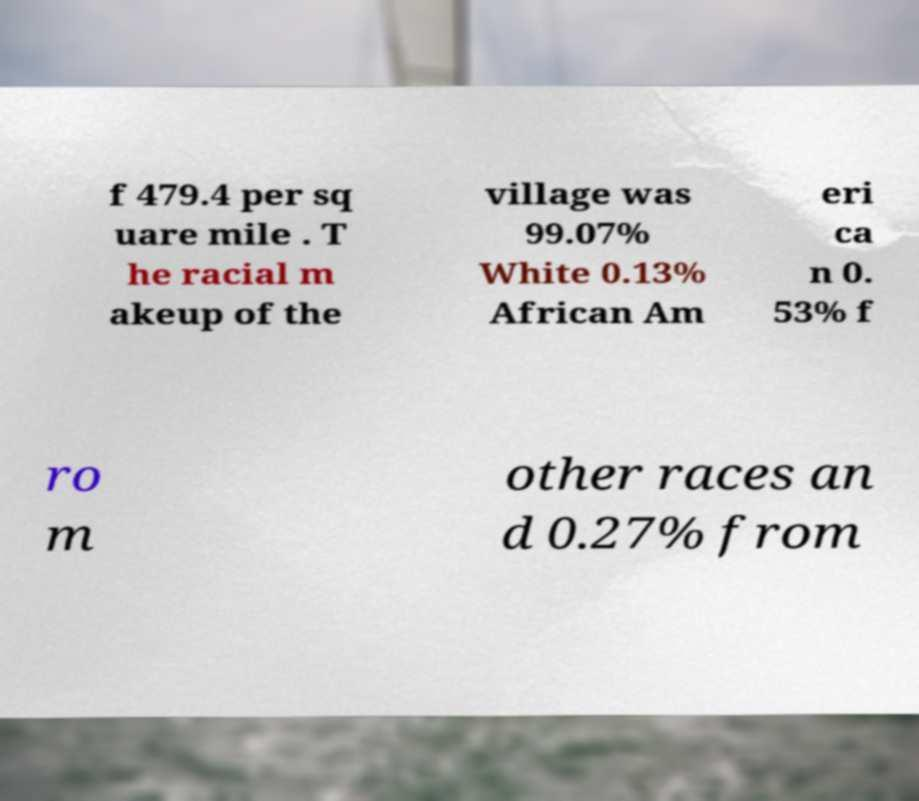Can you read and provide the text displayed in the image?This photo seems to have some interesting text. Can you extract and type it out for me? f 479.4 per sq uare mile . T he racial m akeup of the village was 99.07% White 0.13% African Am eri ca n 0. 53% f ro m other races an d 0.27% from 